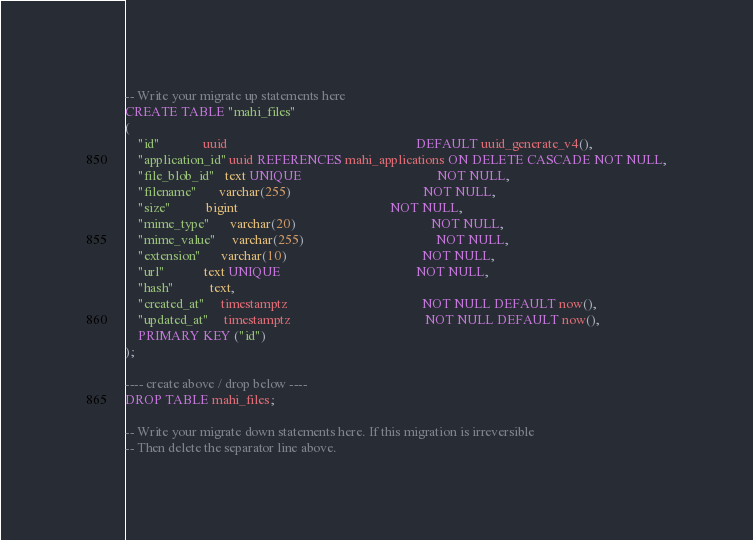Convert code to text. <code><loc_0><loc_0><loc_500><loc_500><_SQL_>-- Write your migrate up statements here
CREATE TABLE "mahi_files"
(
    "id"             uuid                                                         DEFAULT uuid_generate_v4(),
    "application_id" uuid REFERENCES mahi_applications ON DELETE CASCADE NOT NULL,
    "file_blob_id"   text UNIQUE                                         NOT NULL,
    "filename"       varchar(255)                                        NOT NULL,
    "size"           bigint                                              NOT NULL,
    "mime_type"      varchar(20)                                         NOT NULL,
    "mime_value"     varchar(255)                                        NOT NULL,
    "extension"      varchar(10)                                         NOT NULL,
    "url"            text UNIQUE                                         NOT NULL,
    "hash"           text,
    "created_at"     timestamptz                                         NOT NULL DEFAULT now(),
    "updated_at"     timestamptz                                         NOT NULL DEFAULT now(),
    PRIMARY KEY ("id")
);

---- create above / drop below ----
DROP TABLE mahi_files;

-- Write your migrate down statements here. If this migration is irreversible
-- Then delete the separator line above.
</code> 